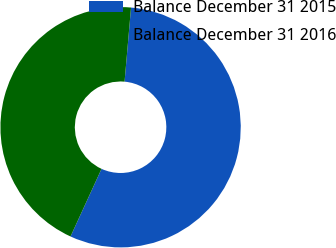Convert chart. <chart><loc_0><loc_0><loc_500><loc_500><pie_chart><fcel>Balance December 31 2015<fcel>Balance December 31 2016<nl><fcel>55.45%<fcel>44.55%<nl></chart> 